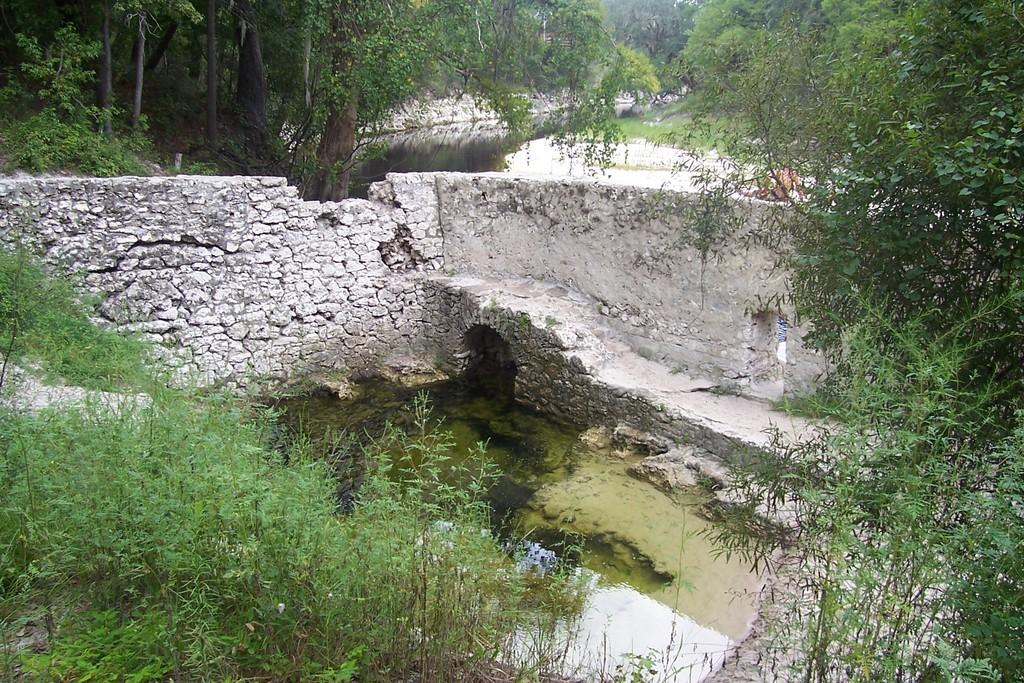What can be seen in the image that provides illumination? There are lights in the image. What type of vegetation is present in the image? There are plants and trees in the image. What natural element is visible in the image? There is water visible in the image. Can you describe the person in the image? There is a person on the right side of the image. What door does the person on the right side of the image use to enter the room? There is no door visible in the image, so it is not possible to determine which door the person might use. 